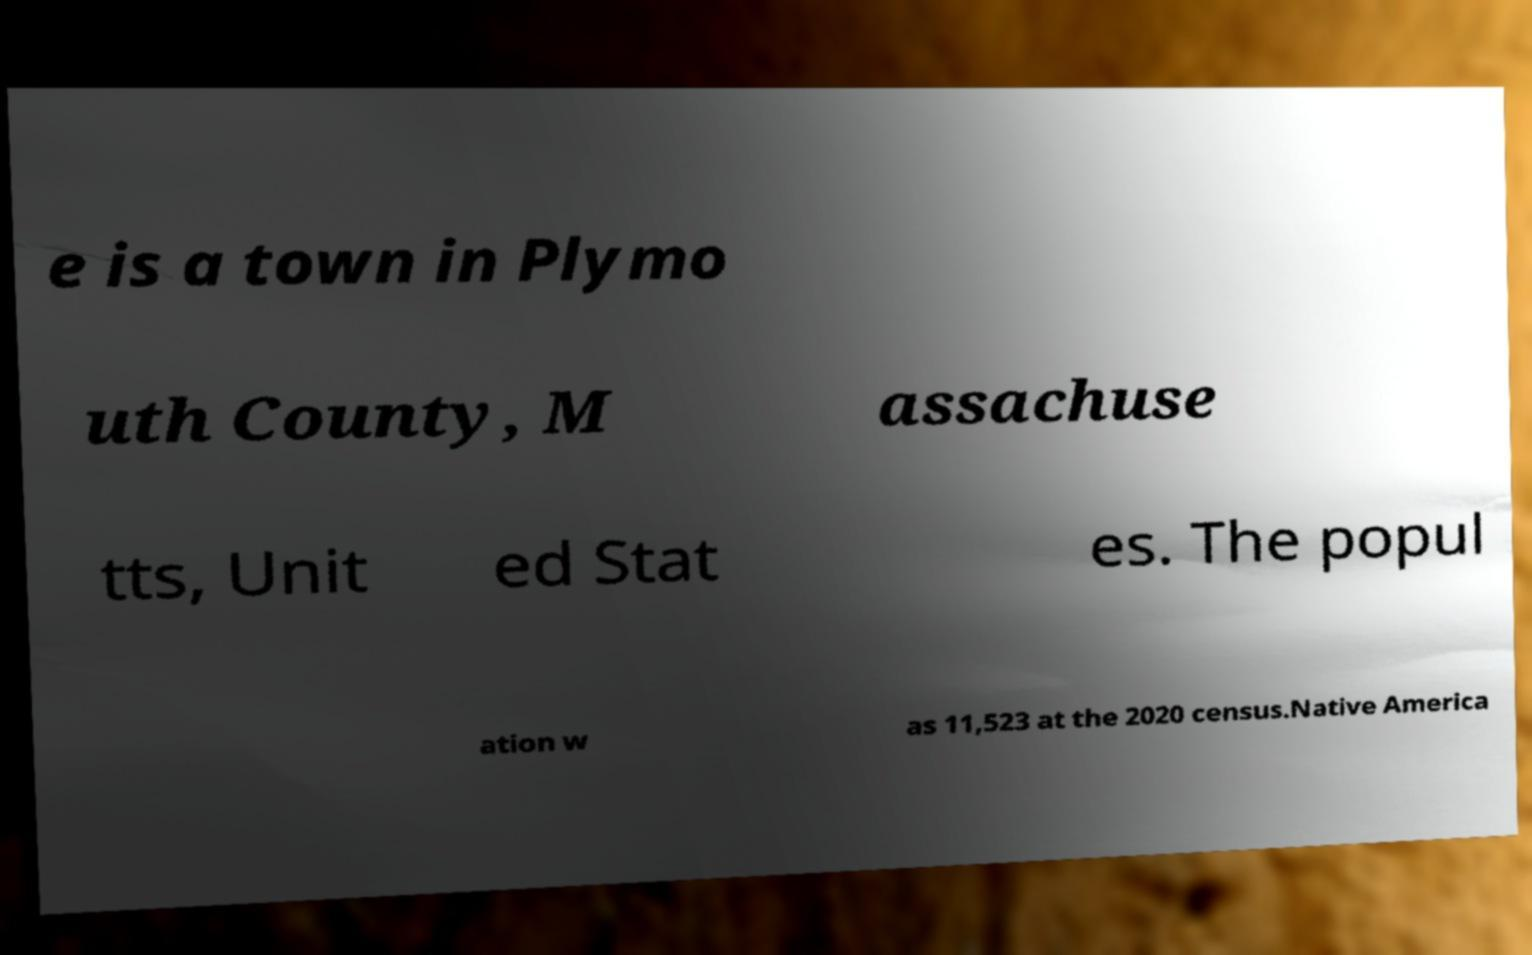Could you extract and type out the text from this image? e is a town in Plymo uth County, M assachuse tts, Unit ed Stat es. The popul ation w as 11,523 at the 2020 census.Native America 